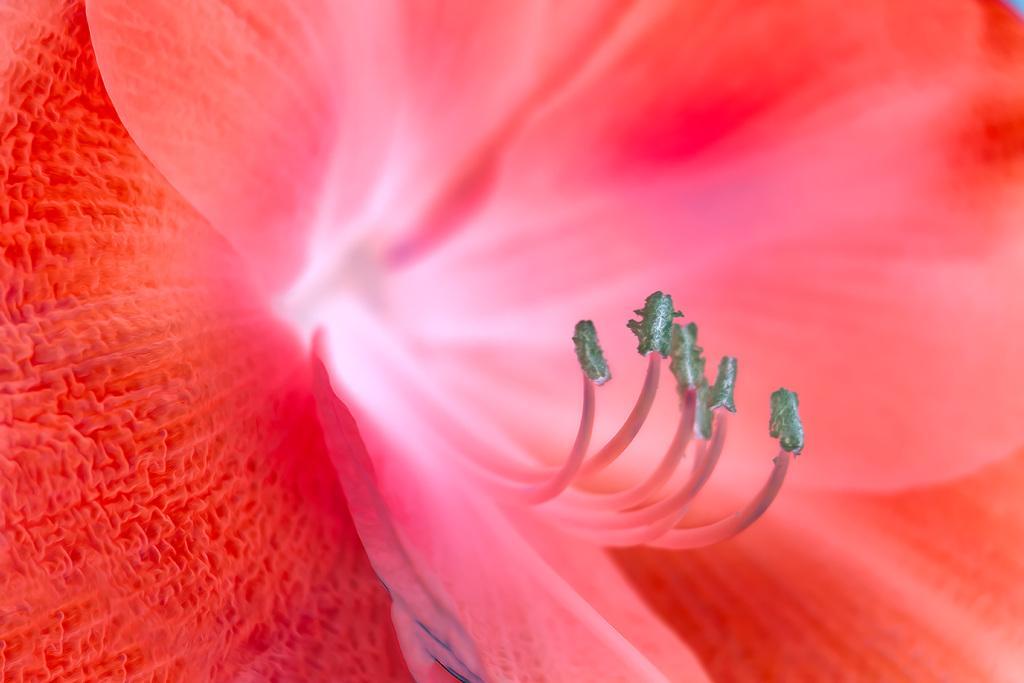Describe this image in one or two sentences. This is a zoomed in picture and we can see the petals and some parts of the flower. 